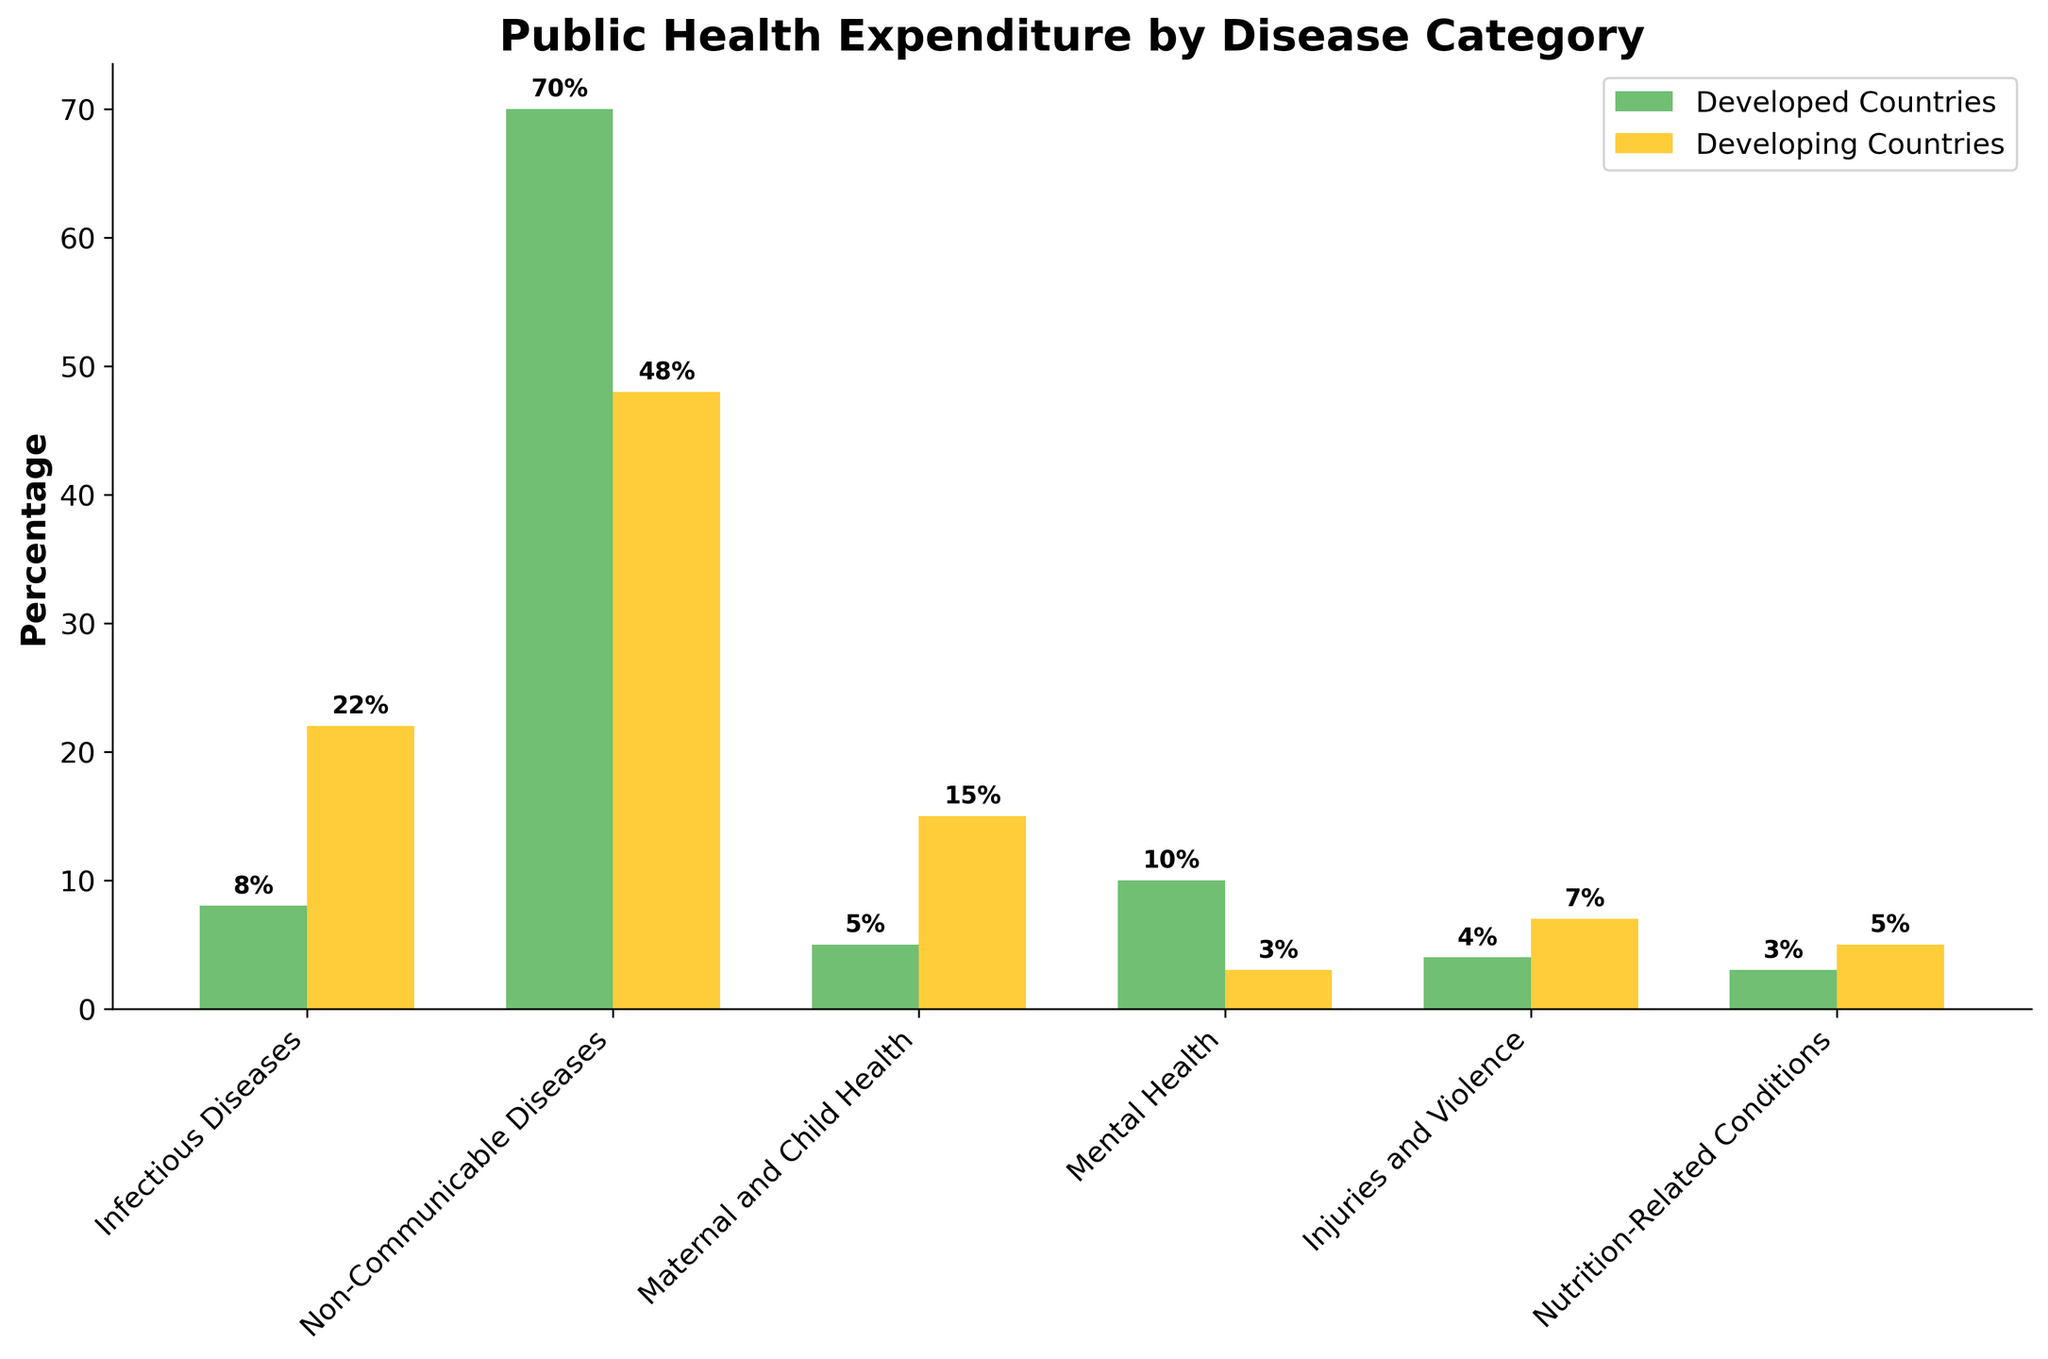Which disease category has the highest percentage of public health expenditure in developed countries? The bar representing Non-Communicable Diseases is the tallest among those for developed countries, indicating the highest percentage.
Answer: Non-Communicable Diseases Which disease category has a higher percentage of expenditure in developing countries compared to developed countries? Look for bars that are taller in the developing countries series. The bars for Infectious Diseases, Maternal and Child Health, Injuries and Violence, and Nutrition-Related Conditions are taller.
Answer: Infectious Diseases, Maternal and Child Health, Injuries and Violence, Nutrition-Related Conditions How much more or less is spent on Mental Health in developed countries compared to developing countries? Compare the height of the bars for Mental Health in both categories. The bar for developed countries is at 10%, and for developing countries, it is at 3%. The difference is 10% - 3% = 7%.
Answer: 7% more What is the combined percentage of expenditure on Infectious Diseases and Non-Communicable Diseases in developing countries? Add the percentages of Infectious Diseases (22%) to Non-Communicable Diseases (48%) for developing countries. The sum is 22% + 48% = 70%.
Answer: 70% On which category do developed countries spend more than 60% of their public health expenditure? Identify the category for developed countries with a bar height greater than 60%. Non-Communicable Diseases at 70% fulfills this condition.
Answer: Non-Communicable Diseases What is the total percentage of public health expenditure on Mental Health and Injuries and Violence in developed countries? Add the percentages for Mental Health (10%) and Injuries and Violence (4%) in developed countries. The sum is 10% + 4% = 14%.
Answer: 14% 